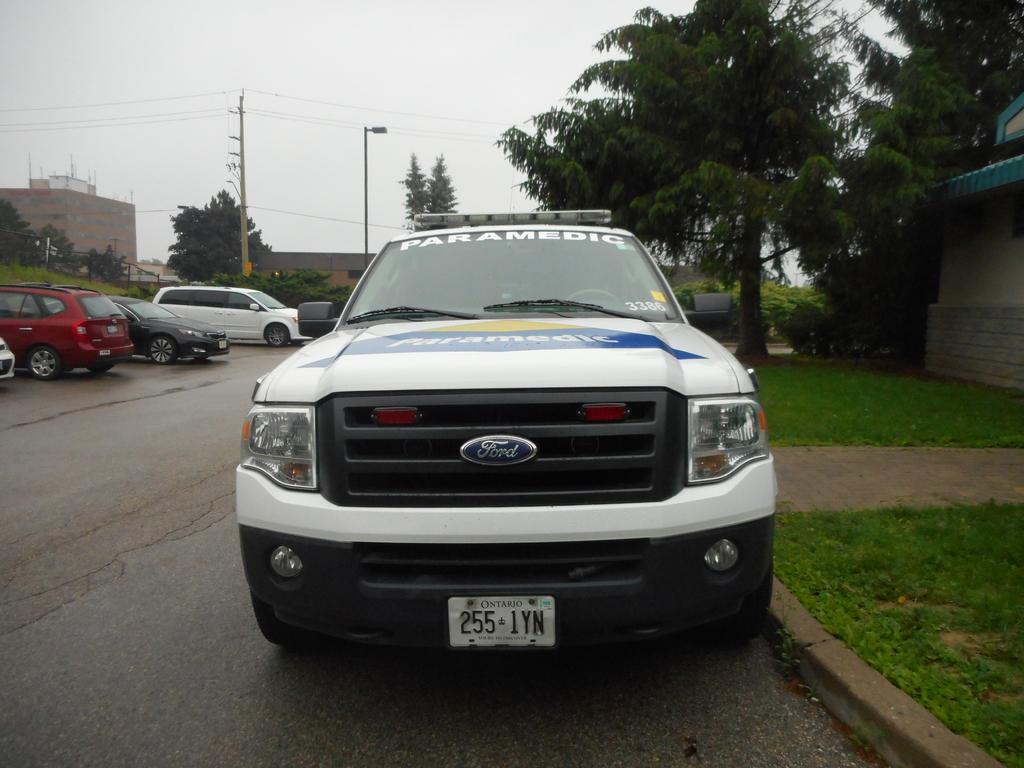Could you give a brief overview of what you see in this image? This picture is clicked outside. In the center we can see the group of cats seems to be parked on the ground and we can see the green grass, trees, poles, cables, street light and buildings. In the background we can see the sky, trees and some other objects. 